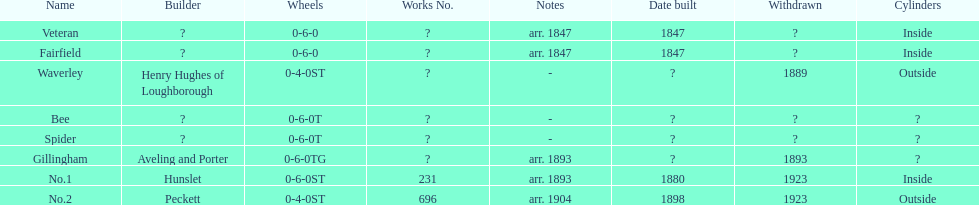Other than fairfield, what else was built in 1847? Veteran. Could you help me parse every detail presented in this table? {'header': ['Name', 'Builder', 'Wheels', 'Works No.', 'Notes', 'Date built', 'Withdrawn', 'Cylinders'], 'rows': [['Veteran', '?', '0-6-0', '?', 'arr. 1847', '1847', '?', 'Inside'], ['Fairfield', '?', '0-6-0', '?', 'arr. 1847', '1847', '?', 'Inside'], ['Waverley', 'Henry Hughes of Loughborough', '0-4-0ST', '?', '-', '?', '1889', 'Outside'], ['Bee', '?', '0-6-0T', '?', '-', '?', '?', '?'], ['Spider', '?', '0-6-0T', '?', '-', '?', '?', '?'], ['Gillingham', 'Aveling and Porter', '0-6-0TG', '?', 'arr. 1893', '?', '1893', '?'], ['No.1', 'Hunslet', '0-6-0ST', '231', 'arr. 1893', '1880', '1923', 'Inside'], ['No.2', 'Peckett', '0-4-0ST', '696', 'arr. 1904', '1898', '1923', 'Outside']]} 